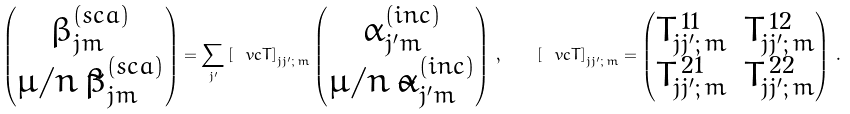<formula> <loc_0><loc_0><loc_500><loc_500>\begin{pmatrix} \beta _ { j m } ^ { ( s c a ) } \\ { \mu } / n \, \tilde { \beta } _ { j m } ^ { ( s c a ) } \end{pmatrix} = \sum _ { j ^ { \prime } } \left [ \ v c { T } \right ] _ { j j ^ { \prime } ; \, m } \begin{pmatrix} \alpha _ { j ^ { \prime } m } ^ { ( i n c ) } \\ { \mu } / n \, \tilde { \alpha } _ { j ^ { \prime } m } ^ { ( i n c ) } \end{pmatrix} \, , \quad \left [ \ v c { T } \right ] _ { j j ^ { \prime } ; \, m } = \begin{pmatrix} T _ { j j ^ { \prime } ; \, m } ^ { \, 1 1 } & T _ { j j ^ { \prime } ; \, m } ^ { \, 1 2 } \\ T _ { j j ^ { \prime } ; \, m } ^ { \, 2 1 } & T _ { j j ^ { \prime } ; \, m } ^ { \, 2 2 } \\ \end{pmatrix} \, .</formula> 